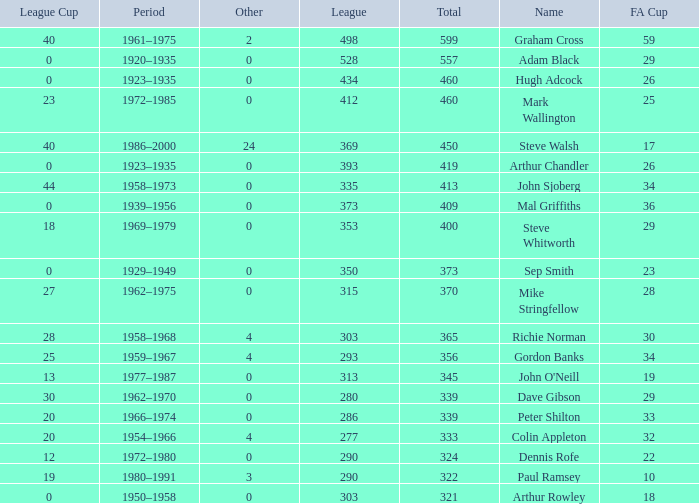What is the lowest number of League Cups a player with a 434 league has? 0.0. 